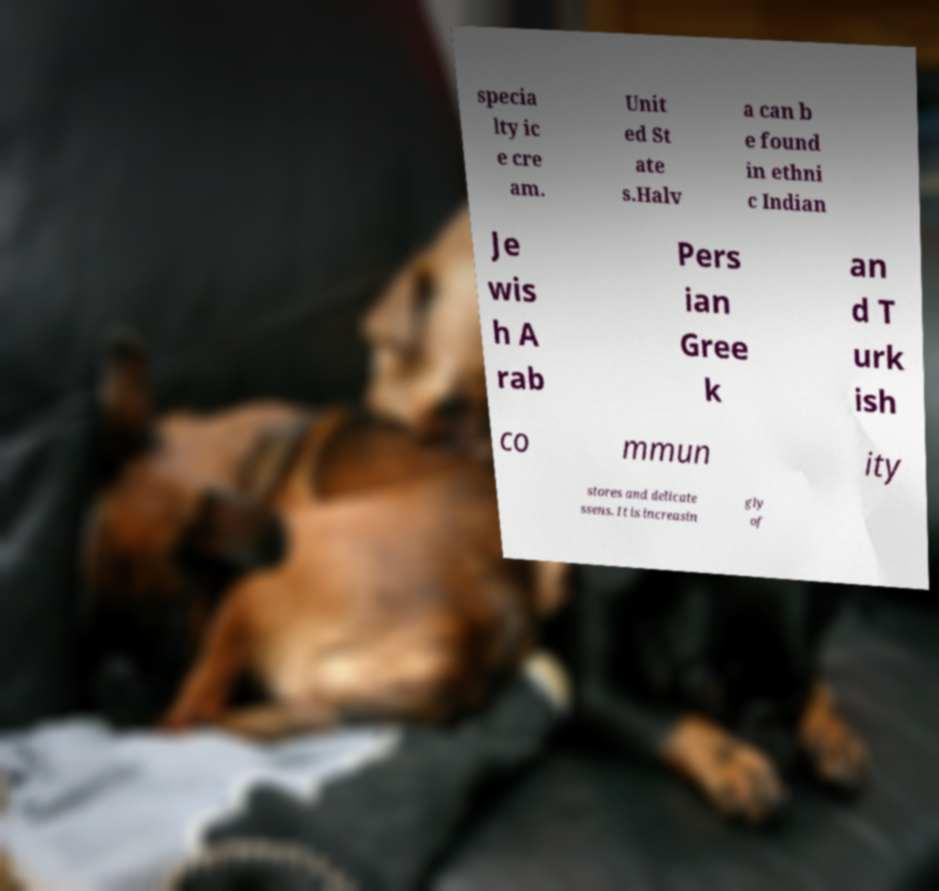Could you assist in decoding the text presented in this image and type it out clearly? specia lty ic e cre am. Unit ed St ate s.Halv a can b e found in ethni c Indian Je wis h A rab Pers ian Gree k an d T urk ish co mmun ity stores and delicate ssens. It is increasin gly of 